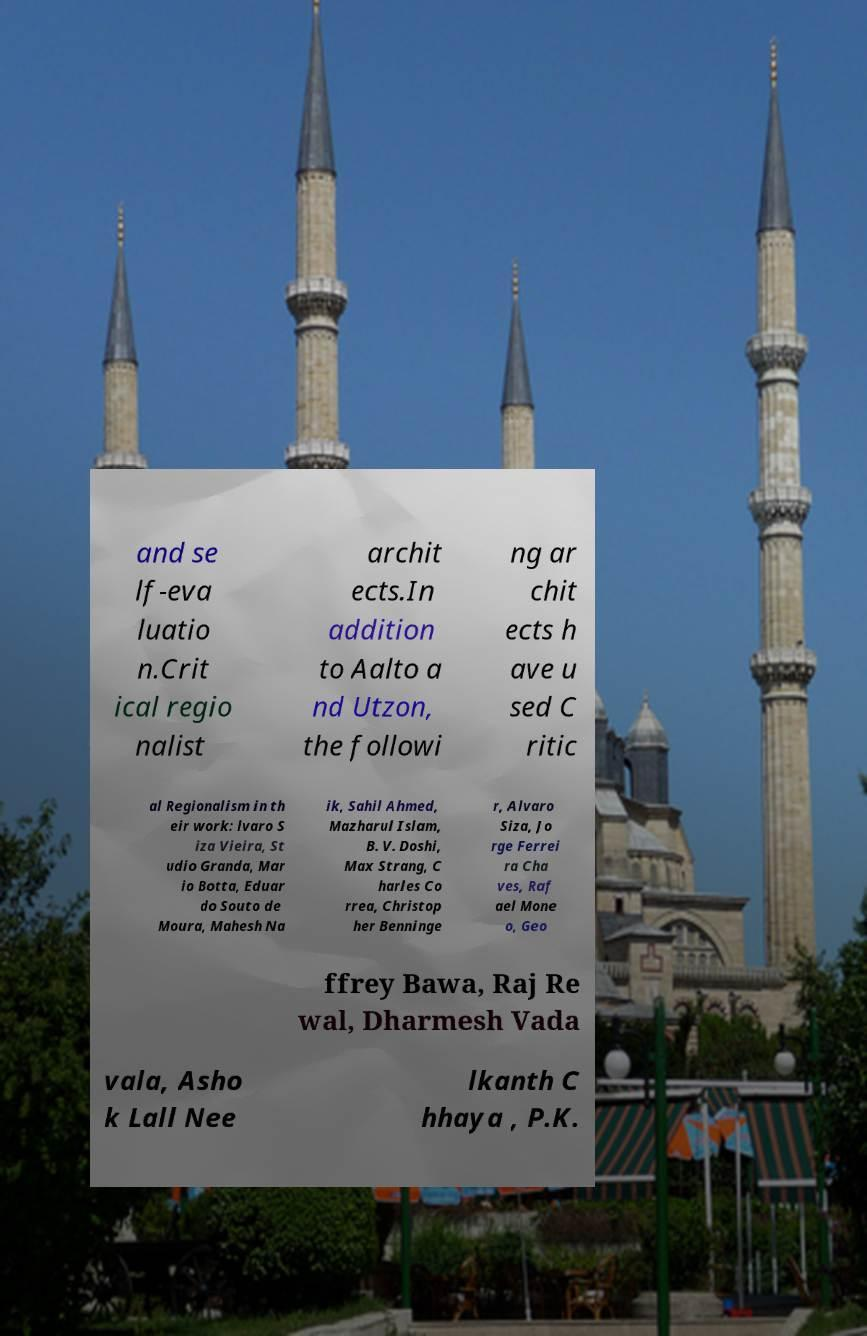What messages or text are displayed in this image? I need them in a readable, typed format. and se lf-eva luatio n.Crit ical regio nalist archit ects.In addition to Aalto a nd Utzon, the followi ng ar chit ects h ave u sed C ritic al Regionalism in th eir work: lvaro S iza Vieira, St udio Granda, Mar io Botta, Eduar do Souto de Moura, Mahesh Na ik, Sahil Ahmed, Mazharul Islam, B. V. Doshi, Max Strang, C harles Co rrea, Christop her Benninge r, Alvaro Siza, Jo rge Ferrei ra Cha ves, Raf ael Mone o, Geo ffrey Bawa, Raj Re wal, Dharmesh Vada vala, Asho k Lall Nee lkanth C hhaya , P.K. 